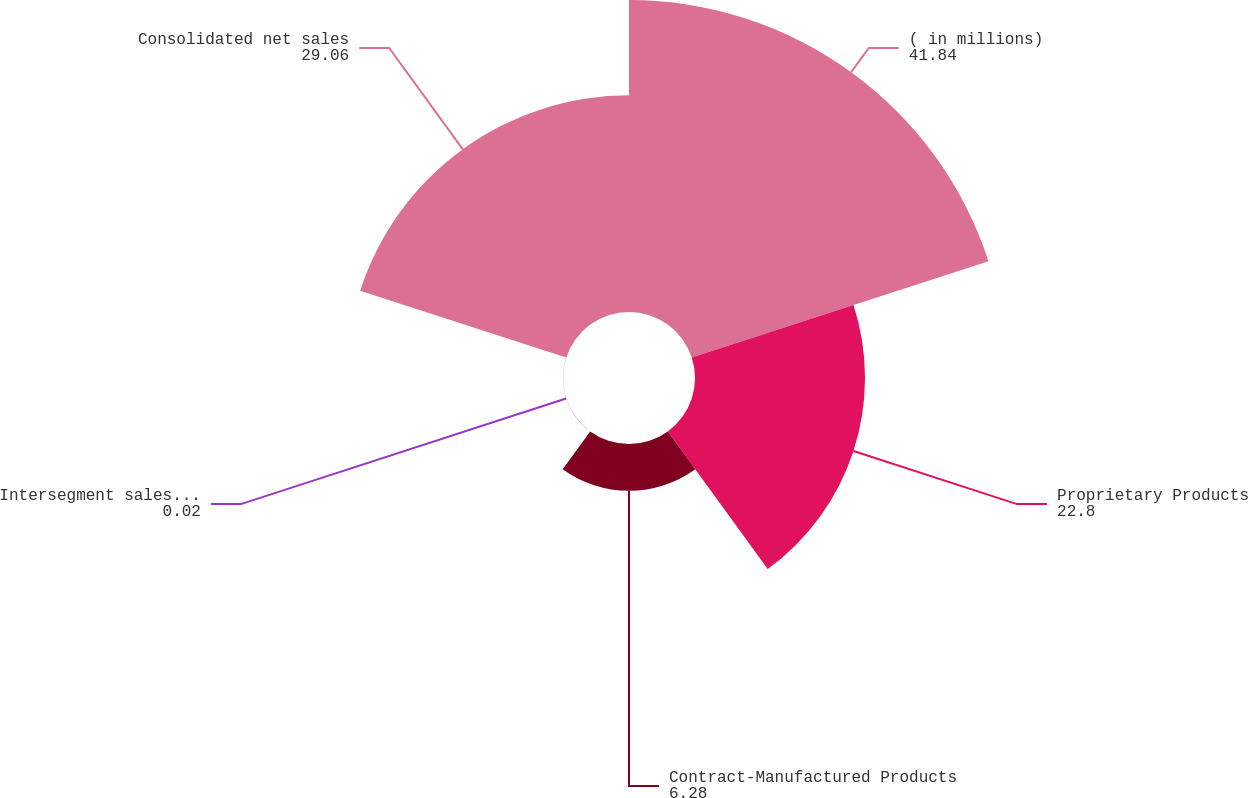Convert chart. <chart><loc_0><loc_0><loc_500><loc_500><pie_chart><fcel>( in millions)<fcel>Proprietary Products<fcel>Contract-Manufactured Products<fcel>Intersegment sales elimination<fcel>Consolidated net sales<nl><fcel>41.84%<fcel>22.8%<fcel>6.28%<fcel>0.02%<fcel>29.06%<nl></chart> 